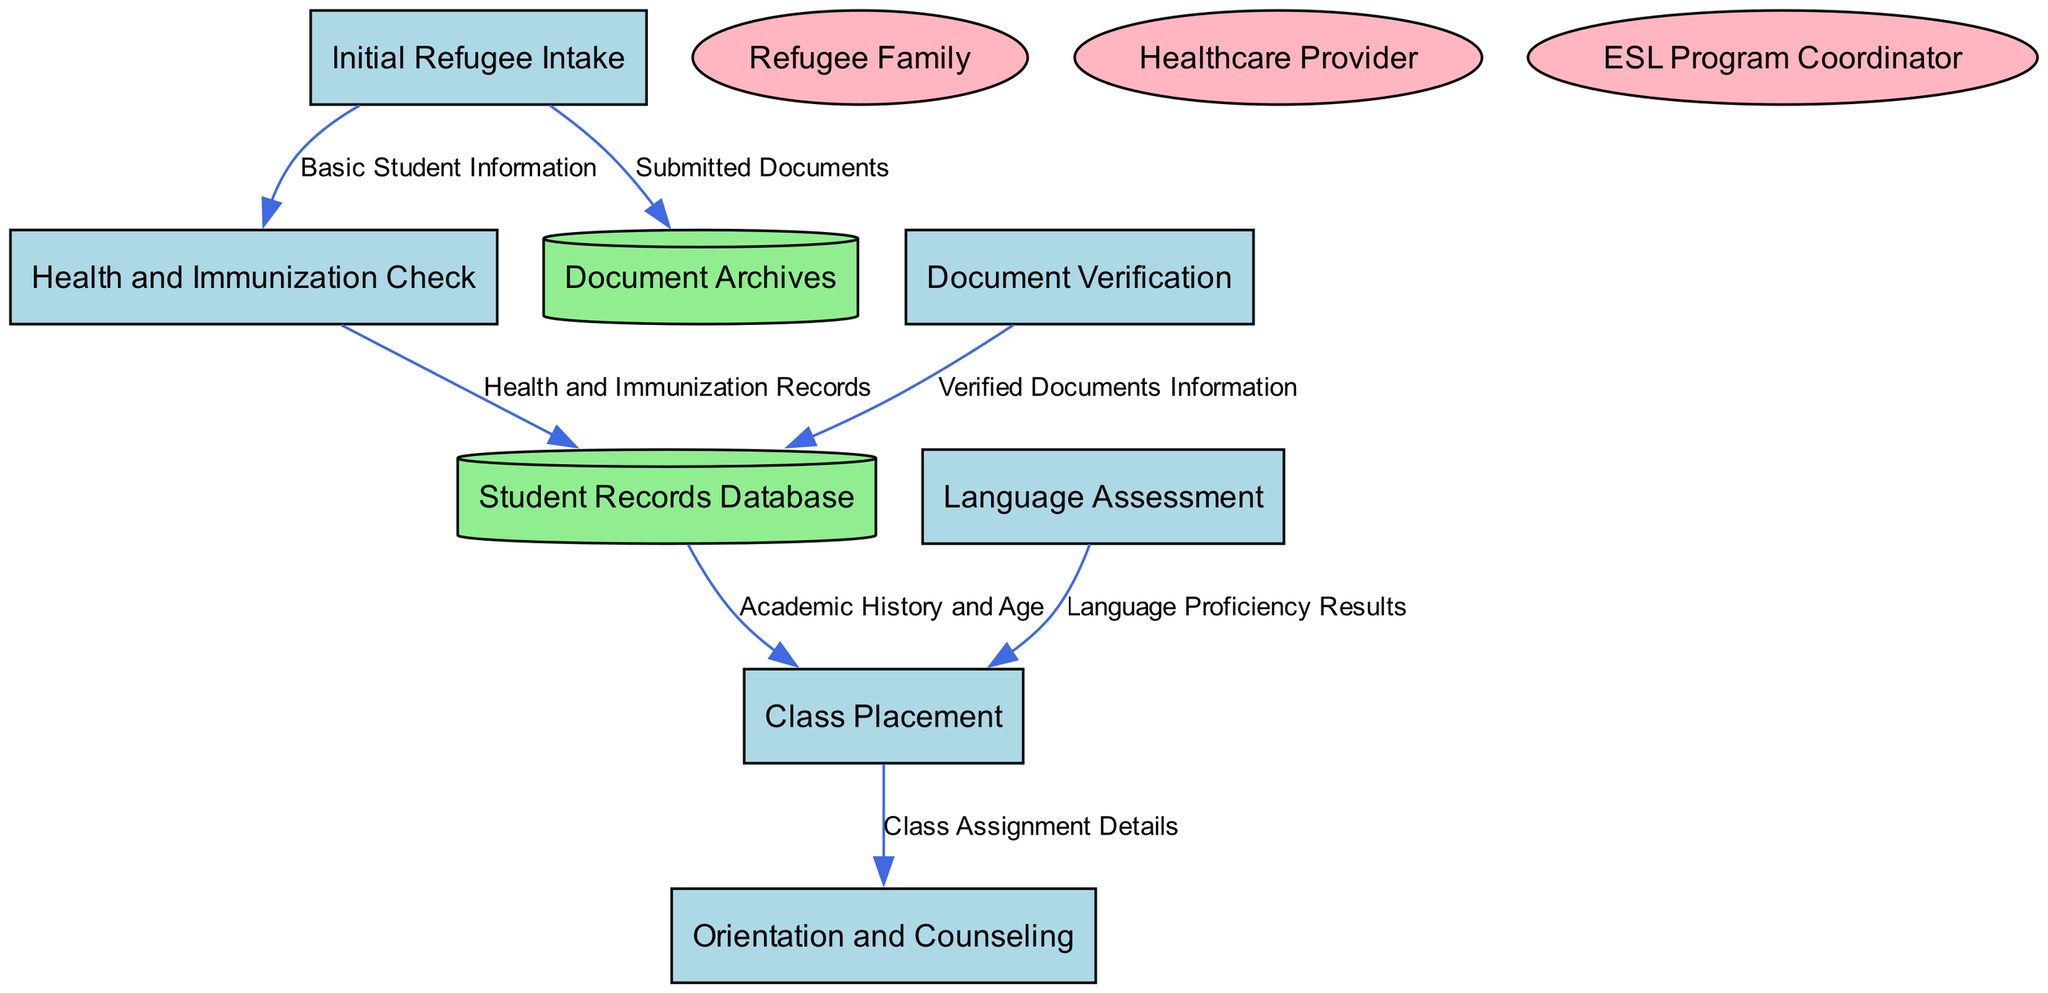What is the first process in the diagram? The first process is labeled as “Initial Refugee Intake,” which is indicated in the diagram as the starting point for collecting information about the refugee student and family's background.
Answer: Initial Refugee Intake How many processes are shown in the diagram? By counting the listed processes in the diagram, we find there are six distinct processes outlined, which are numbered 1 through 6.
Answer: 6 Which data store holds verified documents? The data store called “Document Archives” is responsible for holding scanned copies of all submitted documents for verification purposes, as indicated in the data flows.
Answer: Document Archives What is the data flow from Health and Immunization Check to Student Records Database? The data flow from “Health and Immunization Check” to “Student Records Database” contains “Health and Immunization Records,” which reflects the type of information being stored in the database from this process.
Answer: Health and Immunization Records Which external entity is responsible for conducting the health and immunization check? The external entity that carries out the health and immunization check is described as “Healthcare Provider,” which is identified in the diagram.
Answer: Healthcare Provider What is the final process leading to the Orientation and Counseling? The “Class Placement” process leads directly to “Orientation and Counseling,” as shown in the diagram’s flow, indicating that class assignment details will be provided during orientation.
Answer: Class Placement How does the Language Assessment process influence class placement? The Language Assessment outputs “Language Proficiency Results,” which directly correlate with the Class Placement process to determine appropriate classes for the student based on their language skills.
Answer: Language Proficiency Results How many data flows are present in the diagram? By examining the connections between the processes, data stores, and external entities, we count a total of seven data flows depicted in the diagram.
Answer: 7 What document types are submitted during the Initial Refugee Intake process? The data flow from the “Initial Refugee Intake” process to the “Document Archives” indicates that “Submitted Documents” are the types of documents that are collected at this initial stage.
Answer: Submitted Documents 